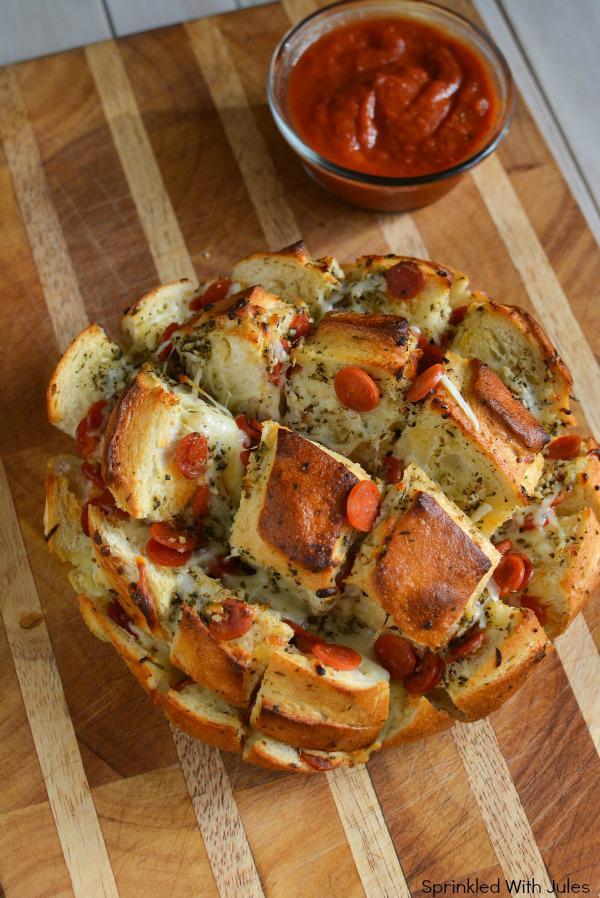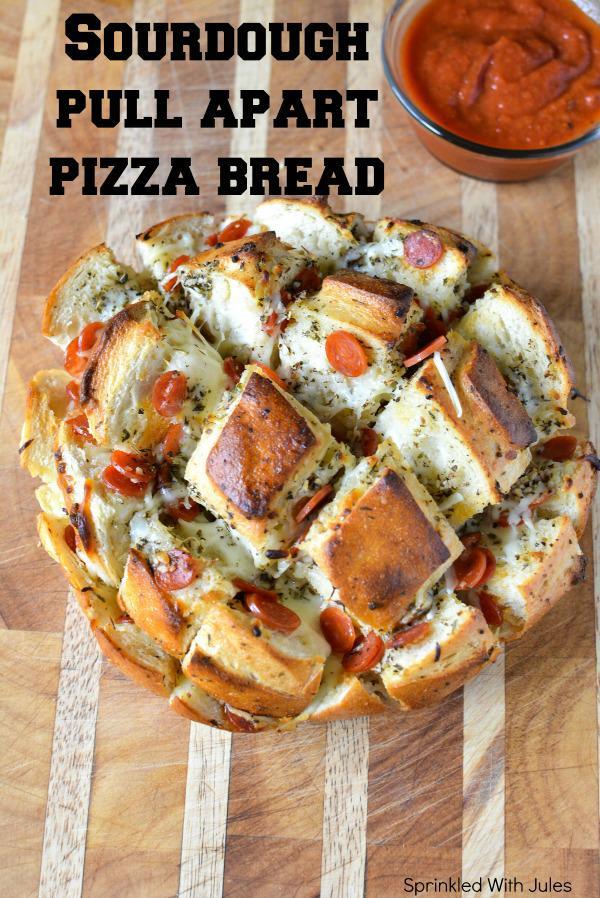The first image is the image on the left, the second image is the image on the right. Evaluate the accuracy of this statement regarding the images: "Both of the pizza breads contain pepperoni.". Is it true? Answer yes or no. Yes. The first image is the image on the left, the second image is the image on the right. Examine the images to the left and right. Is the description "IN at least one image there is a pull apart pizza sitting on a black surface." accurate? Answer yes or no. No. 